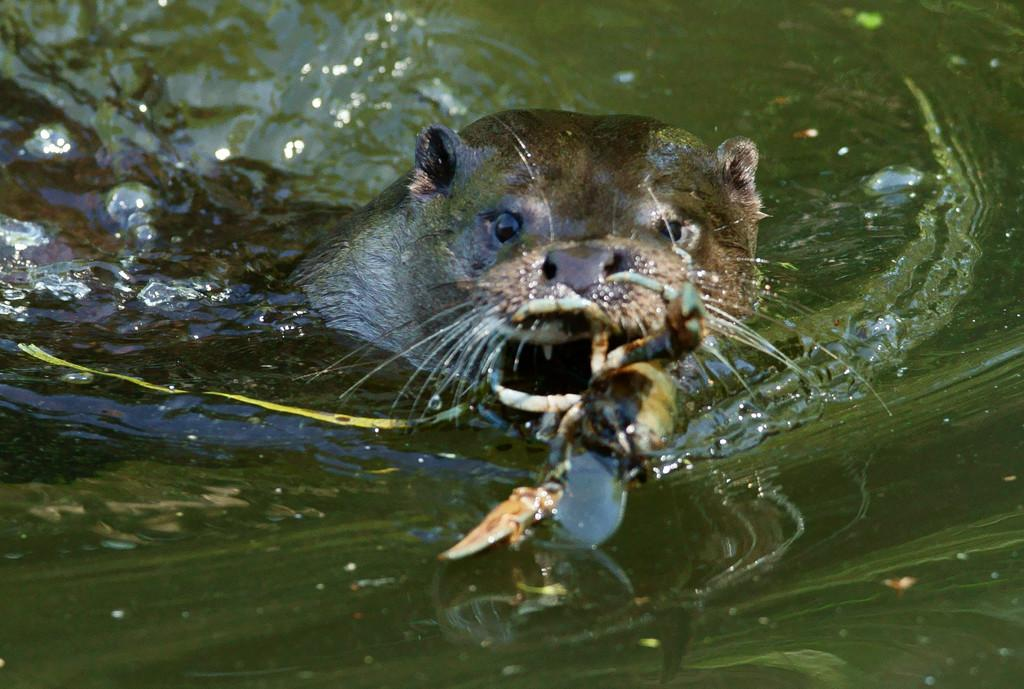What is the animal doing in the water? The animal is holding a crab in the water. Can you describe the animal's activity in the image? The animal is holding a crab, which suggests it might be catching or interacting with the crab. What type of silk is being used to create a yard for the hen in the image? There is no silk, yard, or hen present in the image; it features an animal holding a crab in the water. 